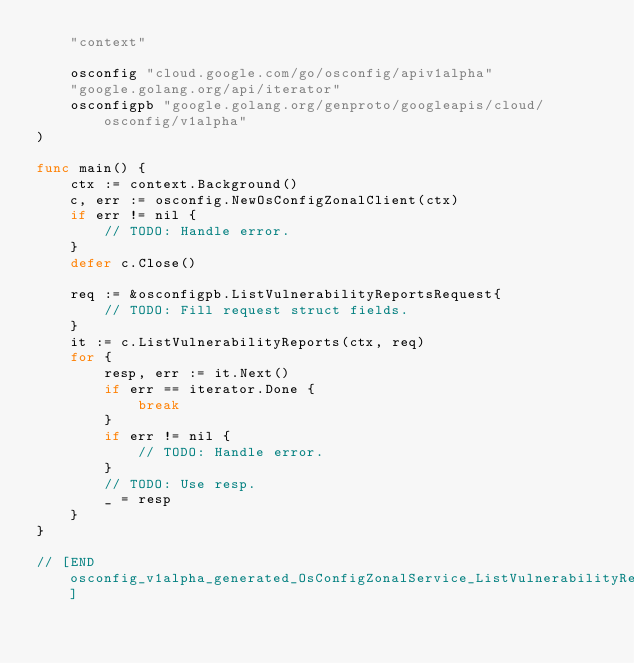Convert code to text. <code><loc_0><loc_0><loc_500><loc_500><_Go_>	"context"

	osconfig "cloud.google.com/go/osconfig/apiv1alpha"
	"google.golang.org/api/iterator"
	osconfigpb "google.golang.org/genproto/googleapis/cloud/osconfig/v1alpha"
)

func main() {
	ctx := context.Background()
	c, err := osconfig.NewOsConfigZonalClient(ctx)
	if err != nil {
		// TODO: Handle error.
	}
	defer c.Close()

	req := &osconfigpb.ListVulnerabilityReportsRequest{
		// TODO: Fill request struct fields.
	}
	it := c.ListVulnerabilityReports(ctx, req)
	for {
		resp, err := it.Next()
		if err == iterator.Done {
			break
		}
		if err != nil {
			// TODO: Handle error.
		}
		// TODO: Use resp.
		_ = resp
	}
}

// [END osconfig_v1alpha_generated_OsConfigZonalService_ListVulnerabilityReports_sync]
</code> 